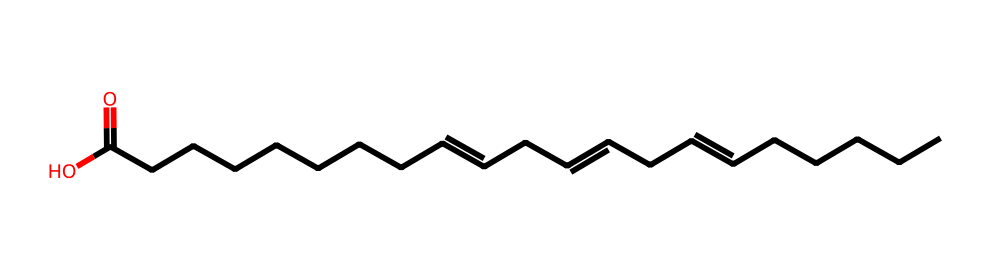How many carbon atoms are in this fatty acid? The SMILES representation shows the structure of the fatty acid including multiple carbon chains. Counting the "C" characters in the structure, there are 18 carbon atoms total.
Answer: 18 What type of bond connects the carbon atoms in the chain? The structure shows both single and double bonds between carbon atoms. The double bonds are indicated by the "=" symbols. Therefore, the carbon atoms are connected by single and double bonds.
Answer: single and double What is the functional group present in this molecule? The ending part "C(=O)O" indicates the presence of a carboxylic acid functional group, which is characteristic for fatty acids.
Answer: carboxylic acid How many double bonds are present in this fatty acid? By examining the SMILES structure, the "=" symbols indicate the presence of double bonds. There are three instances of double bonds in the chain.
Answer: 3 Is this fatty acid saturated or unsaturated? The presence of double bonds (shown as "=" in the SMILES structure) makes this fatty acid unsaturated, as saturated fatty acids only have single bonds.
Answer: unsaturated What is the common name for this type of omega-3 fatty acid? The structural features and the presence of multiple double bonds suggest this is likely alpha-linolenic acid, a common omega-3 fatty acid found in various plant oils.
Answer: alpha-linolenic acid 